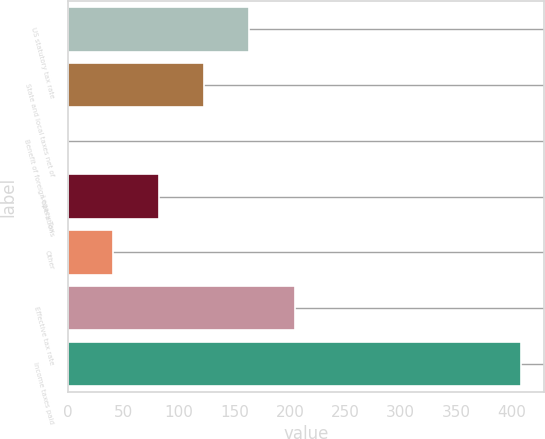<chart> <loc_0><loc_0><loc_500><loc_500><bar_chart><fcel>US statutory tax rate<fcel>State and local taxes net of<fcel>Benefit of foreign operations<fcel>Legacy Tax<fcel>Other<fcel>Effective tax rate<fcel>Income taxes paid<nl><fcel>163.54<fcel>122.68<fcel>0.1<fcel>81.82<fcel>40.96<fcel>204.4<fcel>408.7<nl></chart> 